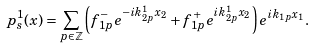Convert formula to latex. <formula><loc_0><loc_0><loc_500><loc_500>p _ { s } ^ { 1 } ( x ) = \sum _ { p \in \mathbb { Z } } \left ( f _ { 1 p } ^ { - } e ^ { - i k _ { 2 p } ^ { 1 } x _ { 2 } } + f _ { 1 p } ^ { + } e ^ { i k _ { 2 p } ^ { 1 } x _ { 2 } } \right ) e ^ { i k _ { 1 p } x _ { 1 } } .</formula> 